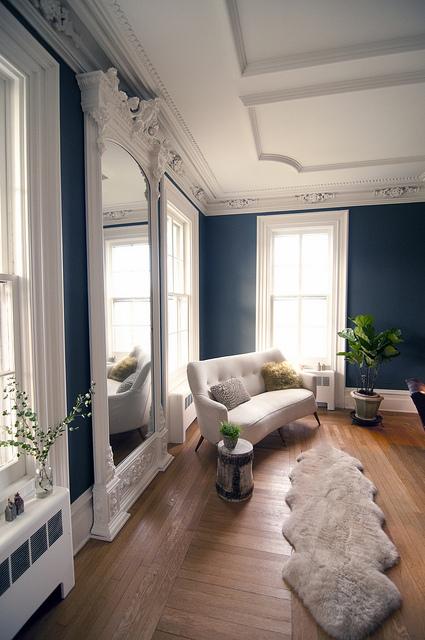What color are the walls?
Concise answer only. Blue. How many plants are there?
Quick response, please. 3. Is the chair white?
Keep it brief. Yes. 